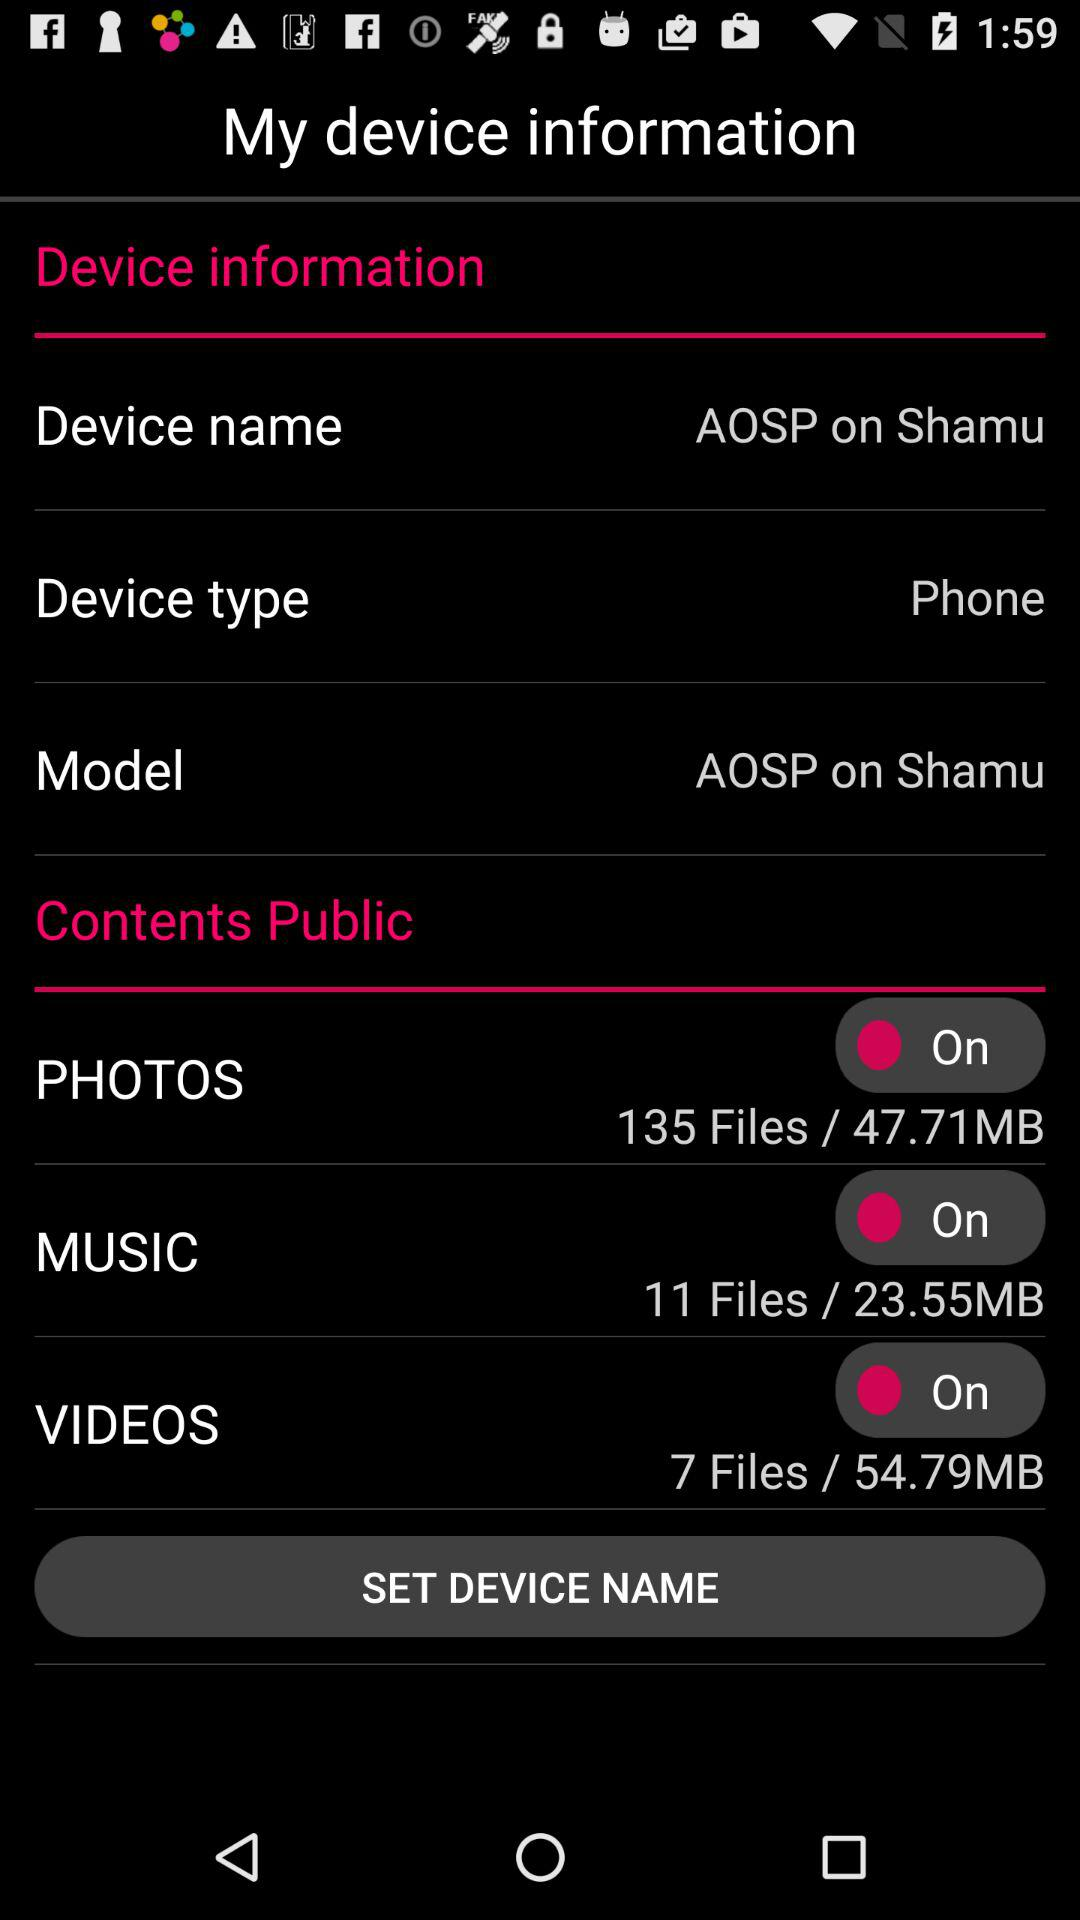How many items are displayed in the contents section?
Answer the question using a single word or phrase. 3 